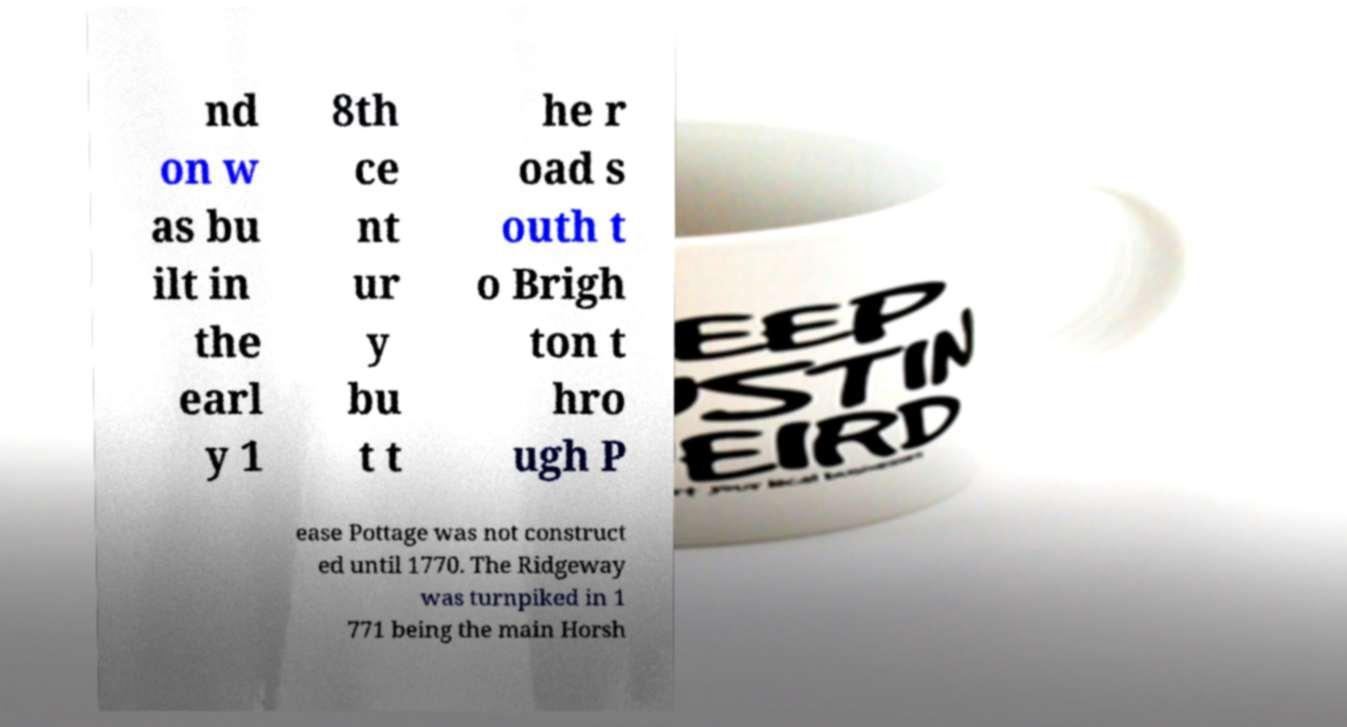I need the written content from this picture converted into text. Can you do that? nd on w as bu ilt in the earl y 1 8th ce nt ur y bu t t he r oad s outh t o Brigh ton t hro ugh P ease Pottage was not construct ed until 1770. The Ridgeway was turnpiked in 1 771 being the main Horsh 